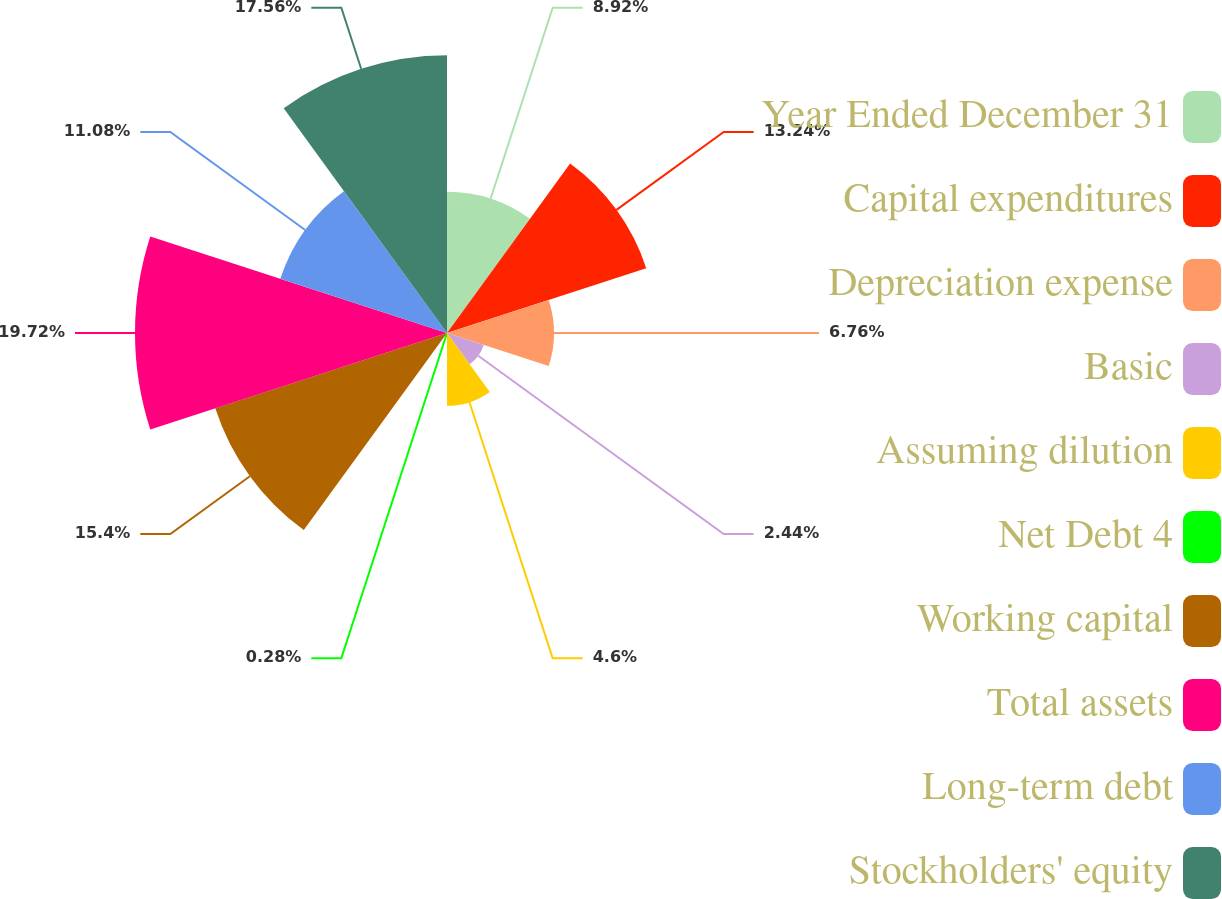Convert chart to OTSL. <chart><loc_0><loc_0><loc_500><loc_500><pie_chart><fcel>Year Ended December 31<fcel>Capital expenditures<fcel>Depreciation expense<fcel>Basic<fcel>Assuming dilution<fcel>Net Debt 4<fcel>Working capital<fcel>Total assets<fcel>Long-term debt<fcel>Stockholders' equity<nl><fcel>8.92%<fcel>13.24%<fcel>6.76%<fcel>2.44%<fcel>4.6%<fcel>0.28%<fcel>15.4%<fcel>19.72%<fcel>11.08%<fcel>17.56%<nl></chart> 